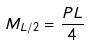Convert formula to latex. <formula><loc_0><loc_0><loc_500><loc_500>M _ { L / 2 } = \frac { P L } { 4 }</formula> 